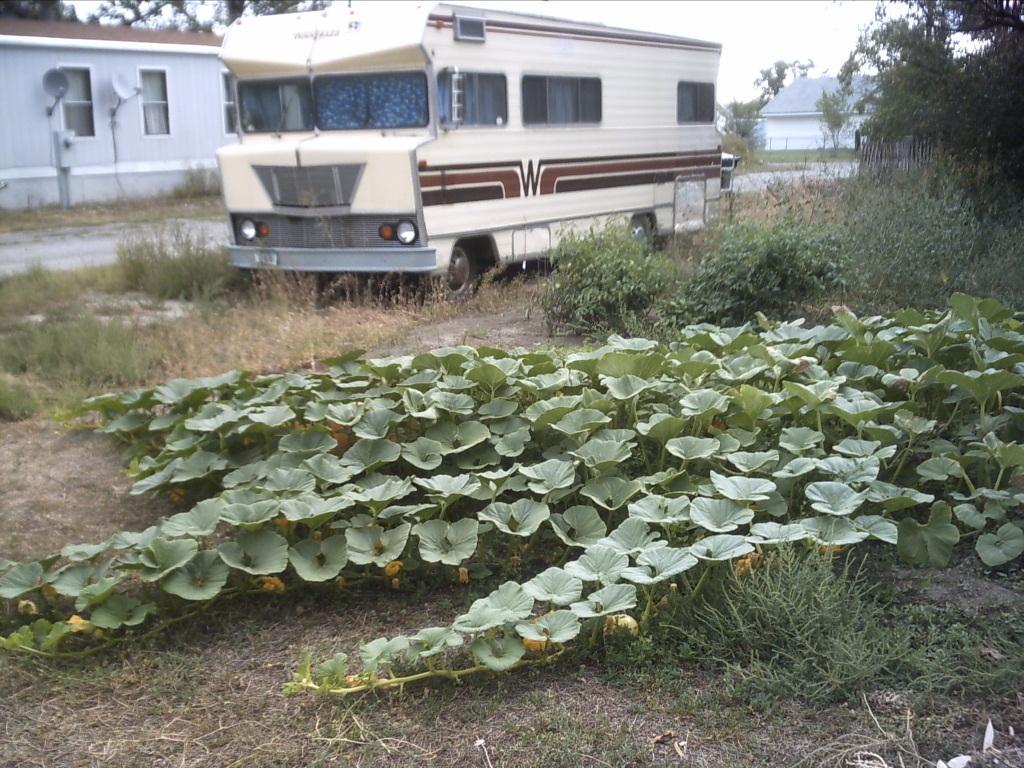In one or two sentences, can you explain what this image depicts? In this picture I can see that there is truck parked here and there are plants, trees and buildings in the backdrop. 